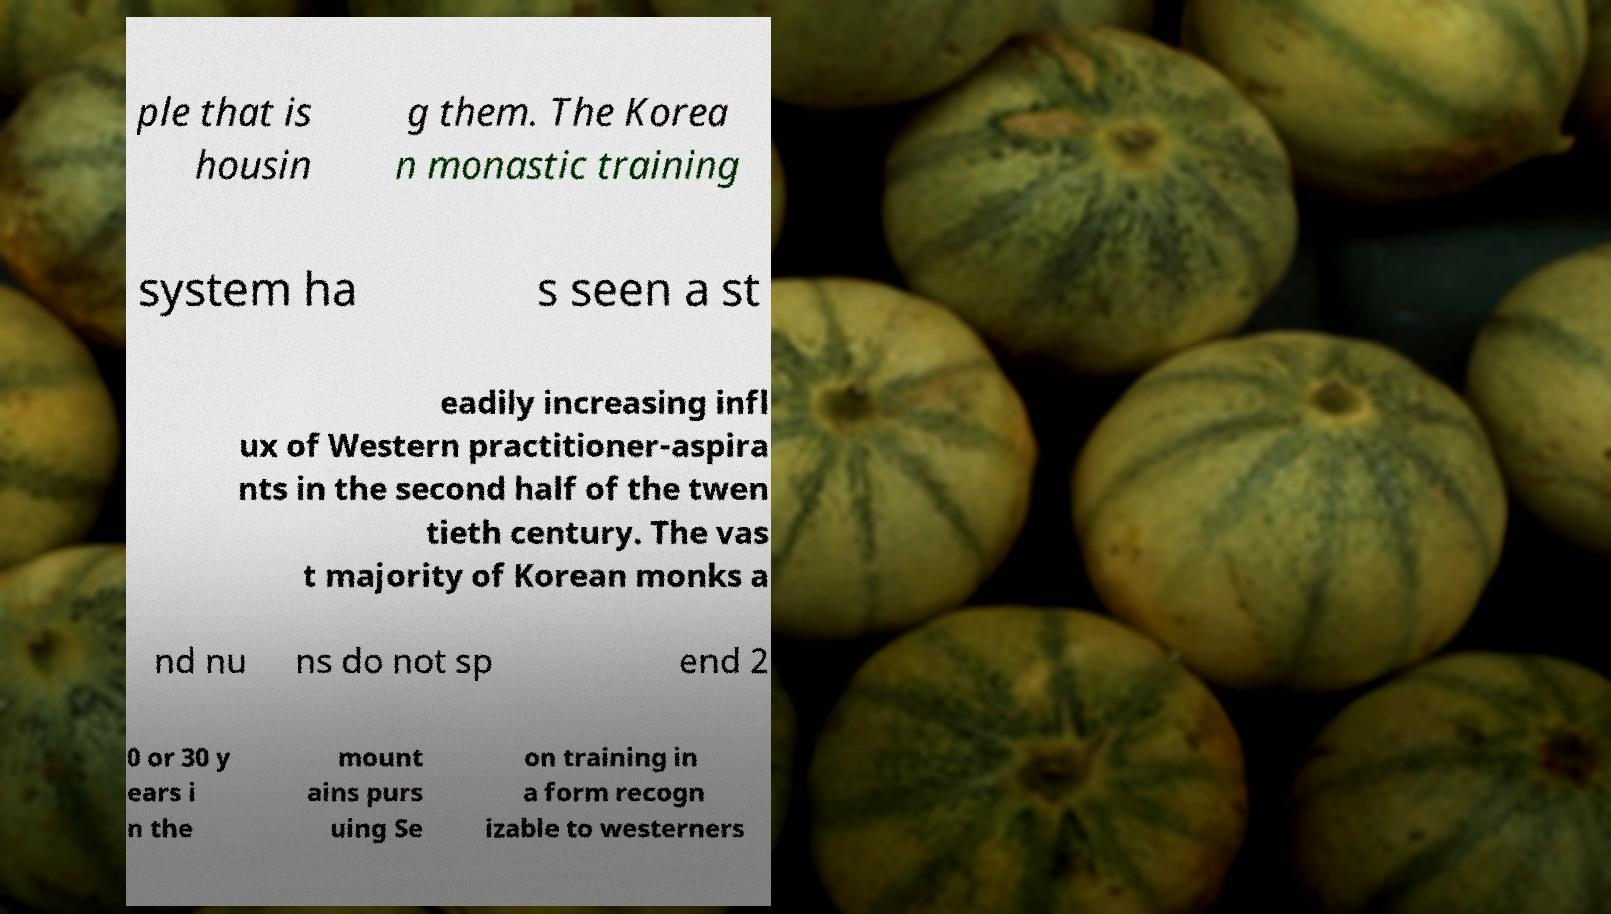Can you accurately transcribe the text from the provided image for me? ple that is housin g them. The Korea n monastic training system ha s seen a st eadily increasing infl ux of Western practitioner-aspira nts in the second half of the twen tieth century. The vas t majority of Korean monks a nd nu ns do not sp end 2 0 or 30 y ears i n the mount ains purs uing Se on training in a form recogn izable to westerners 